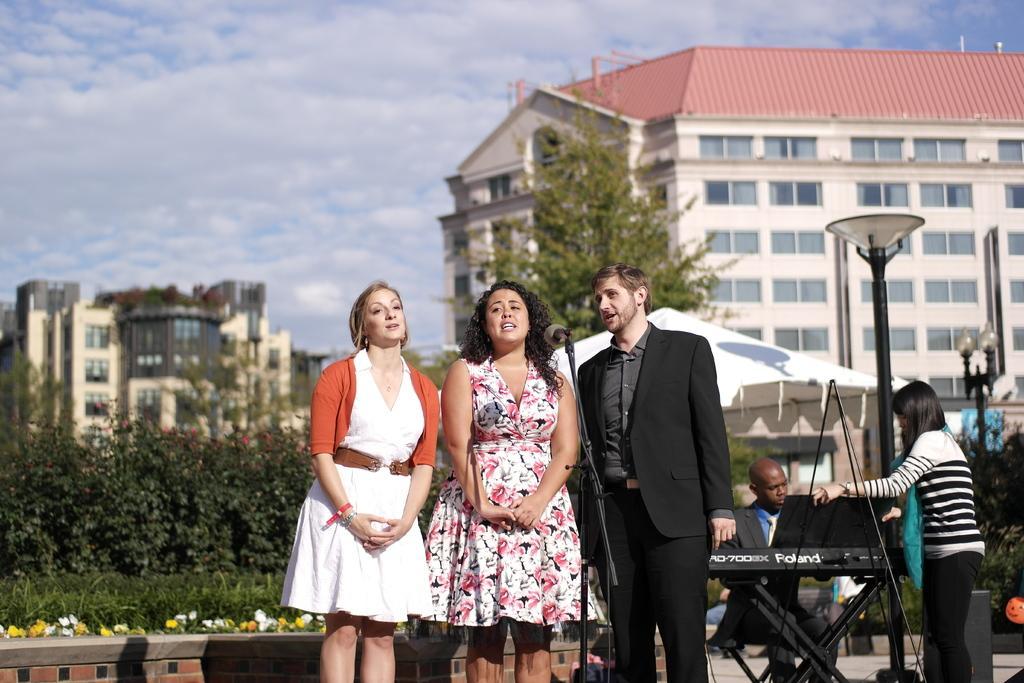In one or two sentences, can you explain what this image depicts? In this image I can see three person standing. We can see mic and stand. Back Side I can see few people playing musical instruments. There is a buildings and windows. We can see trees and light-poles. The sky is in blue and white color. 